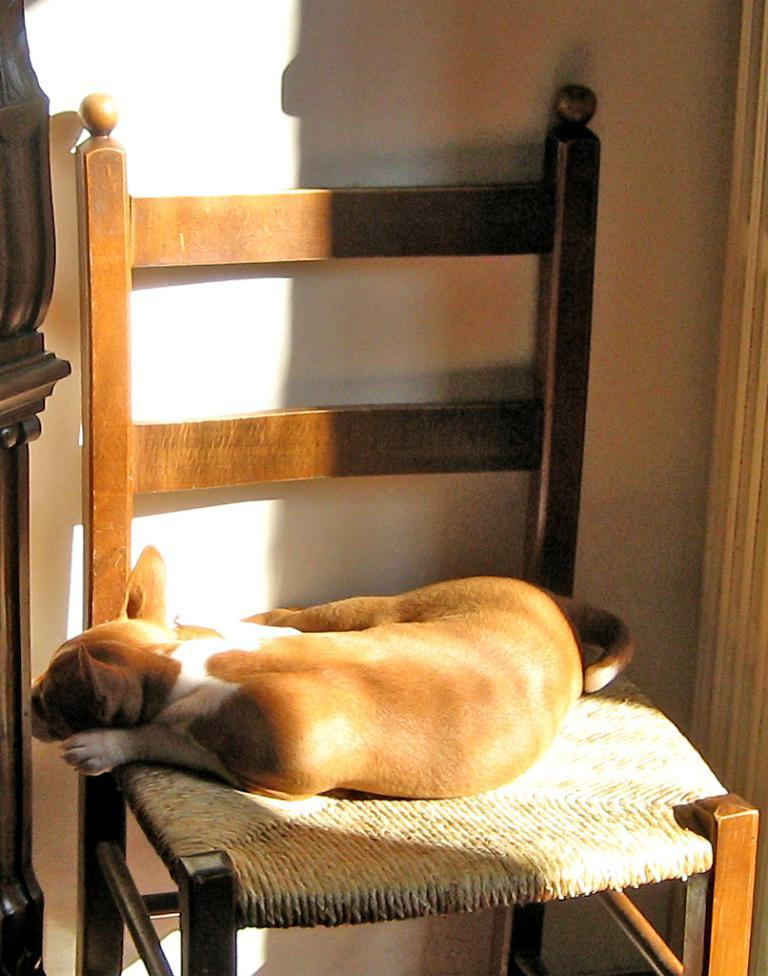What object is present in the image that a person might sit on? There is a chair in the image. What is sitting on the chair in the image? A dog is sitting on the chair in the image. What is the color of the chair? The chair is brown in color. What material is the chair made of? The chair is made of wood. What type of sheet is covering the tree in the image? There is no tree or sheet present in the image. The image only features a chair with a dog sitting on it. 